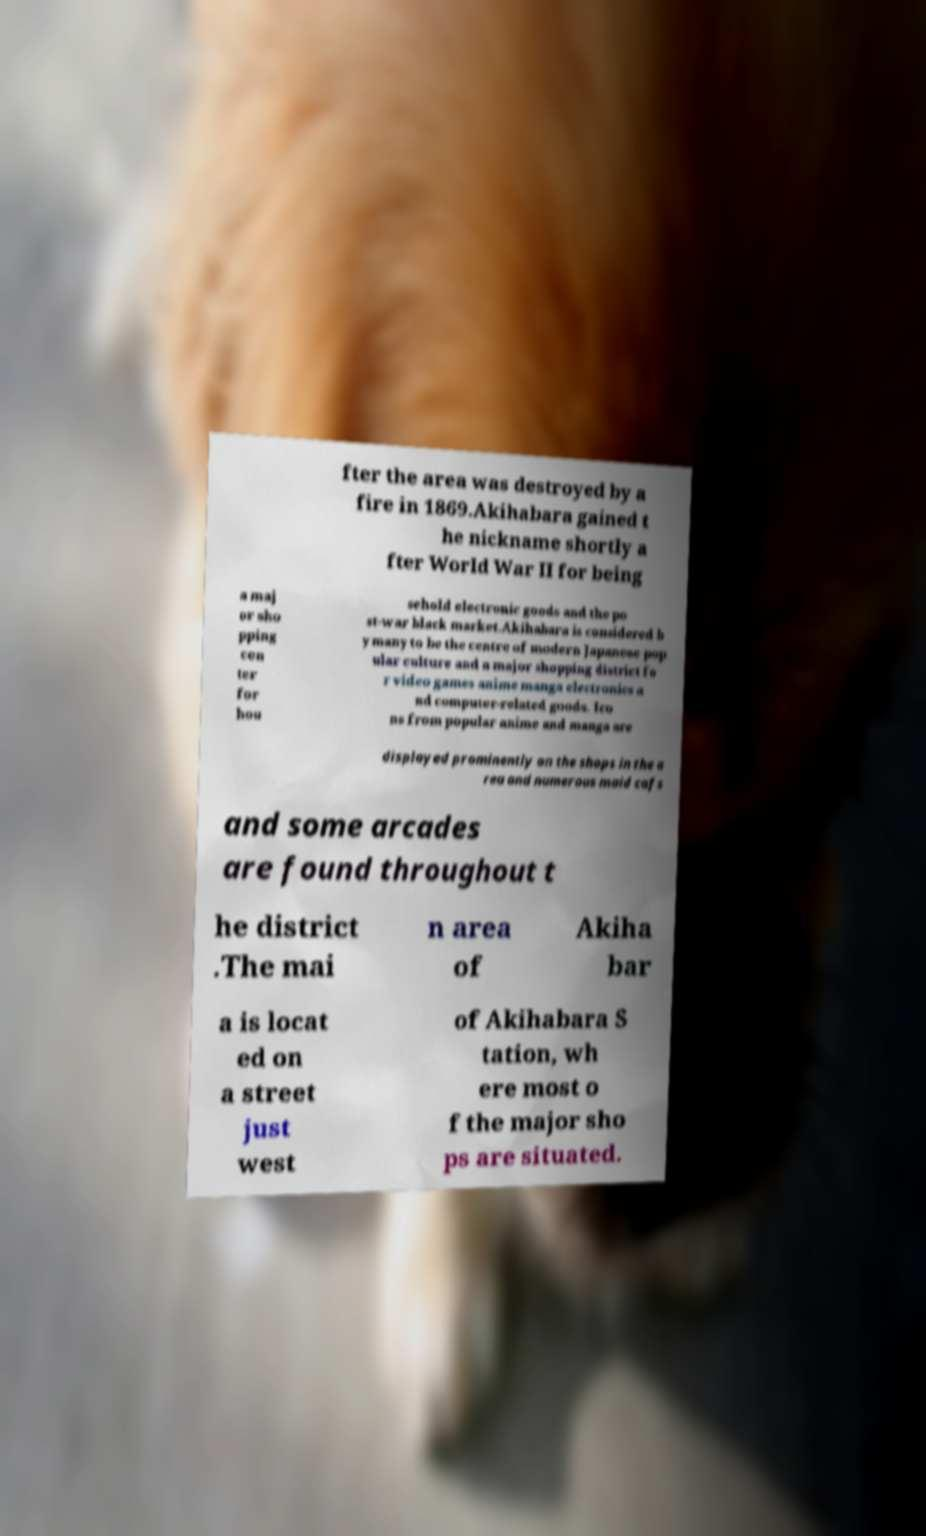Could you assist in decoding the text presented in this image and type it out clearly? fter the area was destroyed by a fire in 1869.Akihabara gained t he nickname shortly a fter World War II for being a maj or sho pping cen ter for hou sehold electronic goods and the po st-war black market.Akihabara is considered b y many to be the centre of modern Japanese pop ular culture and a major shopping district fo r video games anime manga electronics a nd computer-related goods. Ico ns from popular anime and manga are displayed prominently on the shops in the a rea and numerous maid cafs and some arcades are found throughout t he district .The mai n area of Akiha bar a is locat ed on a street just west of Akihabara S tation, wh ere most o f the major sho ps are situated. 